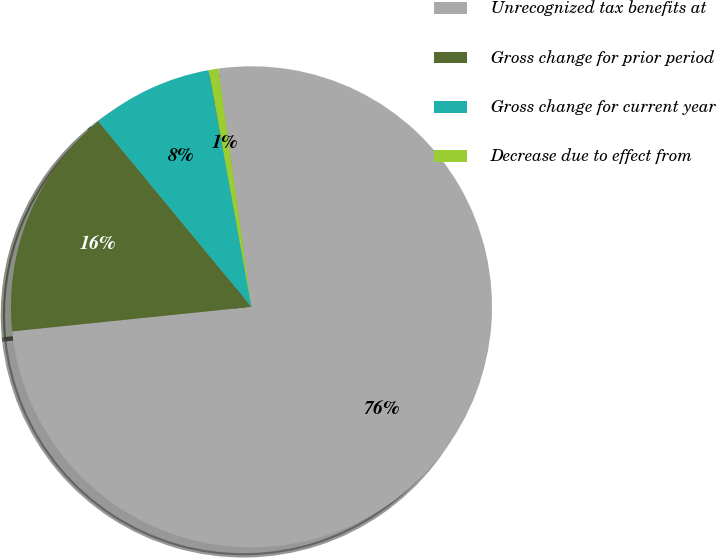Convert chart. <chart><loc_0><loc_0><loc_500><loc_500><pie_chart><fcel>Unrecognized tax benefits at<fcel>Gross change for prior period<fcel>Gross change for current year<fcel>Decrease due to effect from<nl><fcel>75.57%<fcel>15.64%<fcel>8.14%<fcel>0.65%<nl></chart> 